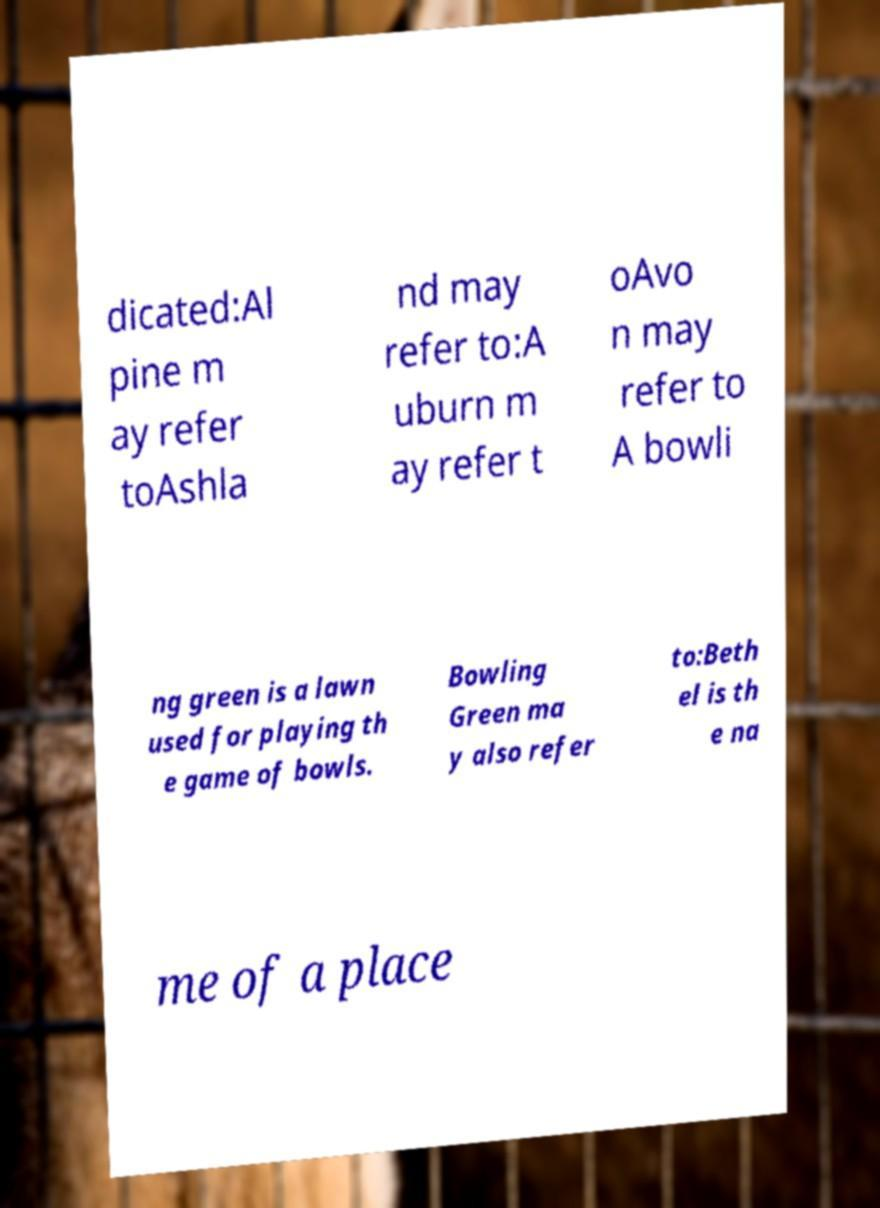Please identify and transcribe the text found in this image. dicated:Al pine m ay refer toAshla nd may refer to:A uburn m ay refer t oAvo n may refer to A bowli ng green is a lawn used for playing th e game of bowls. Bowling Green ma y also refer to:Beth el is th e na me of a place 